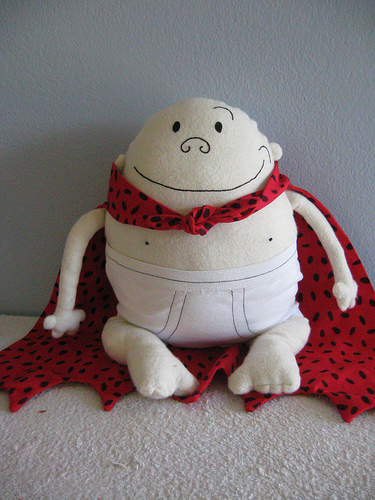<image>
Can you confirm if the underwear is on the carpet? No. The underwear is not positioned on the carpet. They may be near each other, but the underwear is not supported by or resting on top of the carpet. 